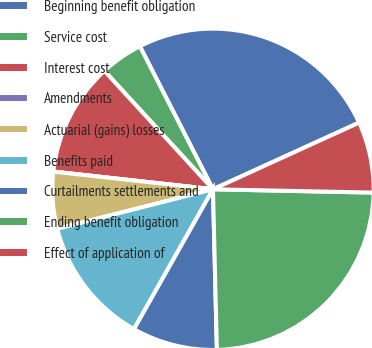Convert chart. <chart><loc_0><loc_0><loc_500><loc_500><pie_chart><fcel>Beginning benefit obligation<fcel>Service cost<fcel>Interest cost<fcel>Amendments<fcel>Actuarial (gains) losses<fcel>Benefits paid<fcel>Curtailments settlements and<fcel>Ending benefit obligation<fcel>Effect of application of<nl><fcel>25.71%<fcel>4.29%<fcel>11.43%<fcel>0.0%<fcel>5.71%<fcel>12.86%<fcel>8.57%<fcel>24.28%<fcel>7.14%<nl></chart> 